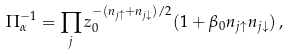<formula> <loc_0><loc_0><loc_500><loc_500>\Pi ^ { - 1 } _ { \alpha } = \prod _ { j } z ^ { - ( n _ { j \uparrow } + n _ { j \downarrow } ) / 2 } _ { 0 } ( 1 + \beta _ { 0 } n _ { j \uparrow } n _ { j \downarrow } ) \, ,</formula> 